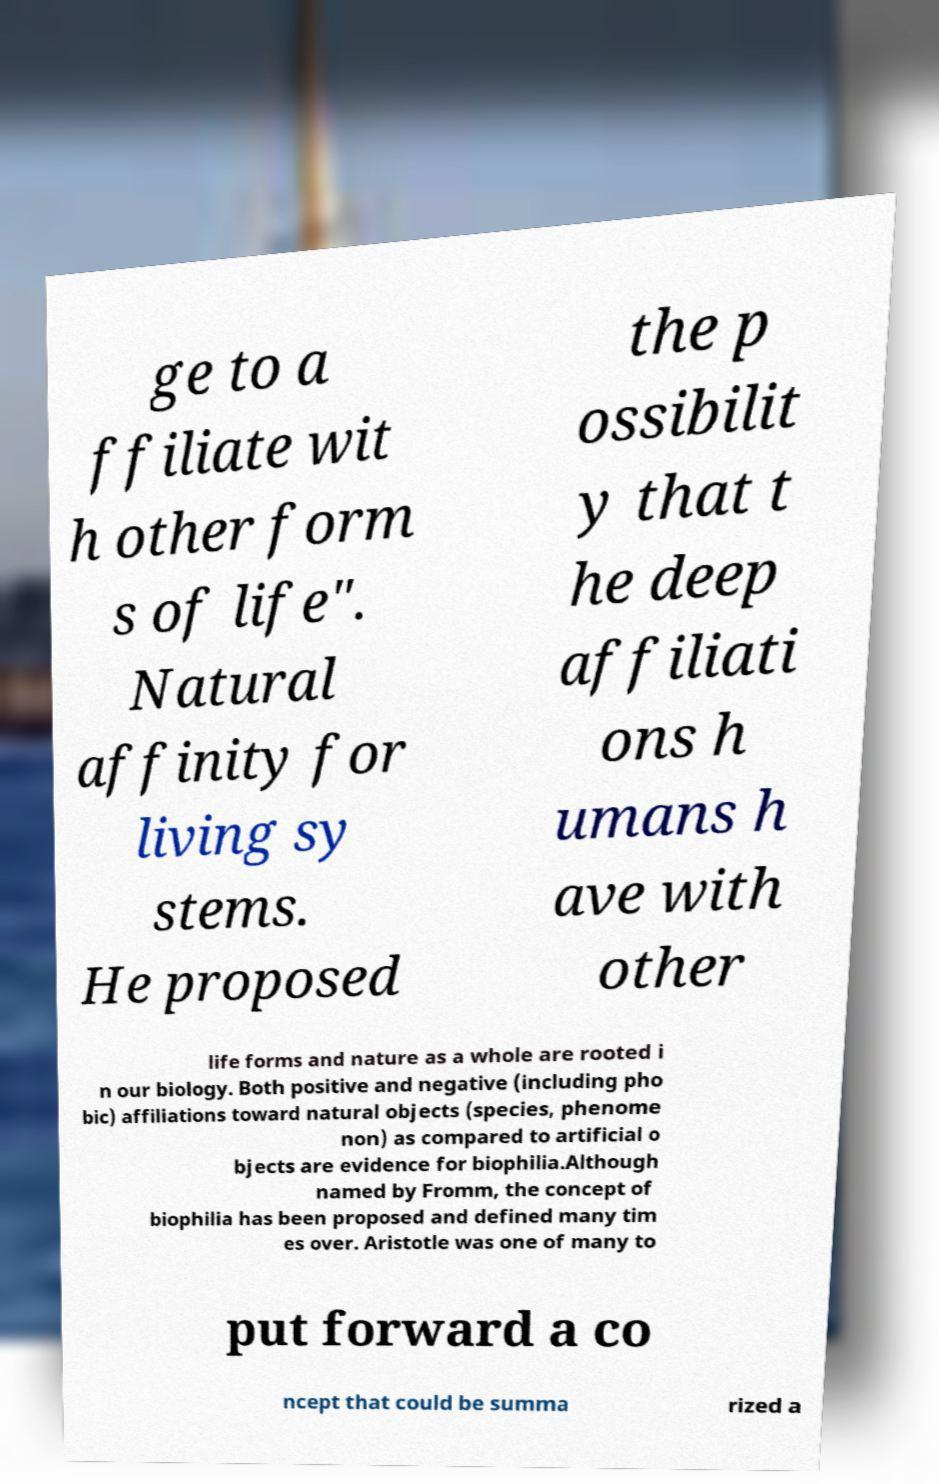There's text embedded in this image that I need extracted. Can you transcribe it verbatim? ge to a ffiliate wit h other form s of life". Natural affinity for living sy stems. He proposed the p ossibilit y that t he deep affiliati ons h umans h ave with other life forms and nature as a whole are rooted i n our biology. Both positive and negative (including pho bic) affiliations toward natural objects (species, phenome non) as compared to artificial o bjects are evidence for biophilia.Although named by Fromm, the concept of biophilia has been proposed and defined many tim es over. Aristotle was one of many to put forward a co ncept that could be summa rized a 